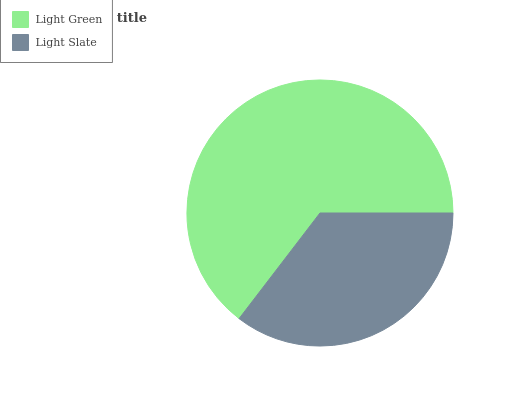Is Light Slate the minimum?
Answer yes or no. Yes. Is Light Green the maximum?
Answer yes or no. Yes. Is Light Slate the maximum?
Answer yes or no. No. Is Light Green greater than Light Slate?
Answer yes or no. Yes. Is Light Slate less than Light Green?
Answer yes or no. Yes. Is Light Slate greater than Light Green?
Answer yes or no. No. Is Light Green less than Light Slate?
Answer yes or no. No. Is Light Green the high median?
Answer yes or no. Yes. Is Light Slate the low median?
Answer yes or no. Yes. Is Light Slate the high median?
Answer yes or no. No. Is Light Green the low median?
Answer yes or no. No. 